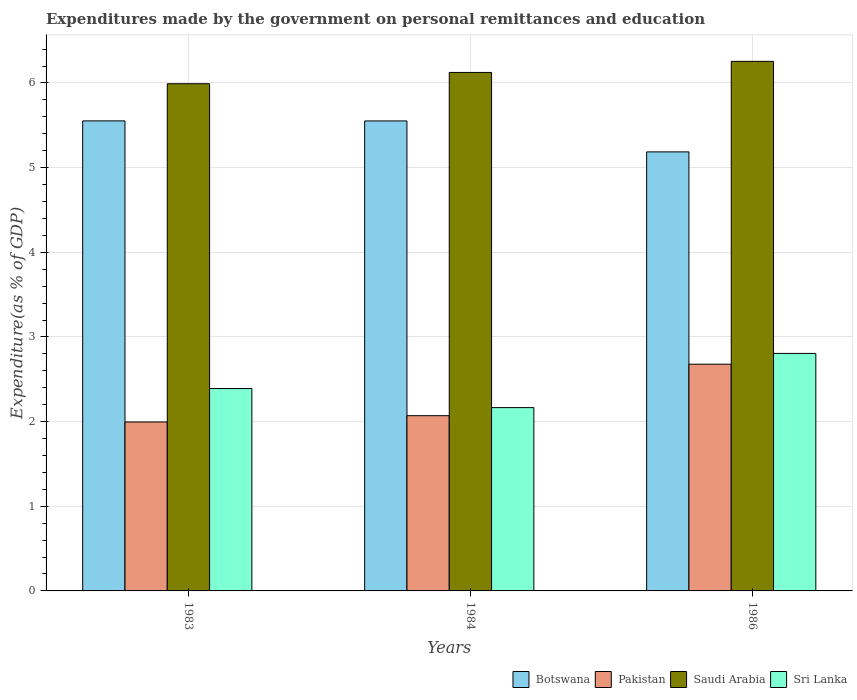How many groups of bars are there?
Provide a short and direct response. 3. Are the number of bars on each tick of the X-axis equal?
Offer a very short reply. Yes. How many bars are there on the 3rd tick from the right?
Offer a terse response. 4. What is the label of the 1st group of bars from the left?
Offer a very short reply. 1983. What is the expenditures made by the government on personal remittances and education in Sri Lanka in 1984?
Your response must be concise. 2.17. Across all years, what is the maximum expenditures made by the government on personal remittances and education in Saudi Arabia?
Your answer should be very brief. 6.26. Across all years, what is the minimum expenditures made by the government on personal remittances and education in Botswana?
Ensure brevity in your answer.  5.19. What is the total expenditures made by the government on personal remittances and education in Pakistan in the graph?
Provide a short and direct response. 6.74. What is the difference between the expenditures made by the government on personal remittances and education in Pakistan in 1983 and that in 1984?
Keep it short and to the point. -0.07. What is the difference between the expenditures made by the government on personal remittances and education in Sri Lanka in 1986 and the expenditures made by the government on personal remittances and education in Pakistan in 1984?
Provide a succinct answer. 0.74. What is the average expenditures made by the government on personal remittances and education in Saudi Arabia per year?
Offer a terse response. 6.12. In the year 1986, what is the difference between the expenditures made by the government on personal remittances and education in Sri Lanka and expenditures made by the government on personal remittances and education in Pakistan?
Provide a short and direct response. 0.13. In how many years, is the expenditures made by the government on personal remittances and education in Pakistan greater than 4.8 %?
Offer a terse response. 0. What is the ratio of the expenditures made by the government on personal remittances and education in Pakistan in 1984 to that in 1986?
Provide a short and direct response. 0.77. Is the expenditures made by the government on personal remittances and education in Saudi Arabia in 1983 less than that in 1986?
Offer a terse response. Yes. What is the difference between the highest and the second highest expenditures made by the government on personal remittances and education in Saudi Arabia?
Make the answer very short. 0.13. What is the difference between the highest and the lowest expenditures made by the government on personal remittances and education in Pakistan?
Give a very brief answer. 0.68. What does the 1st bar from the left in 1984 represents?
Offer a very short reply. Botswana. What does the 4th bar from the right in 1984 represents?
Provide a short and direct response. Botswana. Is it the case that in every year, the sum of the expenditures made by the government on personal remittances and education in Botswana and expenditures made by the government on personal remittances and education in Saudi Arabia is greater than the expenditures made by the government on personal remittances and education in Pakistan?
Your answer should be very brief. Yes. How many bars are there?
Your answer should be very brief. 12. How many years are there in the graph?
Your answer should be compact. 3. Does the graph contain any zero values?
Your response must be concise. No. Does the graph contain grids?
Your response must be concise. Yes. How many legend labels are there?
Give a very brief answer. 4. What is the title of the graph?
Provide a succinct answer. Expenditures made by the government on personal remittances and education. Does "Aruba" appear as one of the legend labels in the graph?
Give a very brief answer. No. What is the label or title of the Y-axis?
Provide a short and direct response. Expenditure(as % of GDP). What is the Expenditure(as % of GDP) in Botswana in 1983?
Your response must be concise. 5.55. What is the Expenditure(as % of GDP) in Pakistan in 1983?
Provide a succinct answer. 2. What is the Expenditure(as % of GDP) in Saudi Arabia in 1983?
Ensure brevity in your answer.  5.99. What is the Expenditure(as % of GDP) in Sri Lanka in 1983?
Provide a succinct answer. 2.39. What is the Expenditure(as % of GDP) in Botswana in 1984?
Your response must be concise. 5.55. What is the Expenditure(as % of GDP) in Pakistan in 1984?
Make the answer very short. 2.07. What is the Expenditure(as % of GDP) of Saudi Arabia in 1984?
Your answer should be compact. 6.12. What is the Expenditure(as % of GDP) of Sri Lanka in 1984?
Make the answer very short. 2.17. What is the Expenditure(as % of GDP) of Botswana in 1986?
Your answer should be compact. 5.19. What is the Expenditure(as % of GDP) in Pakistan in 1986?
Your response must be concise. 2.68. What is the Expenditure(as % of GDP) in Saudi Arabia in 1986?
Provide a short and direct response. 6.26. What is the Expenditure(as % of GDP) in Sri Lanka in 1986?
Your answer should be very brief. 2.81. Across all years, what is the maximum Expenditure(as % of GDP) in Botswana?
Ensure brevity in your answer.  5.55. Across all years, what is the maximum Expenditure(as % of GDP) of Pakistan?
Provide a short and direct response. 2.68. Across all years, what is the maximum Expenditure(as % of GDP) in Saudi Arabia?
Keep it short and to the point. 6.26. Across all years, what is the maximum Expenditure(as % of GDP) in Sri Lanka?
Give a very brief answer. 2.81. Across all years, what is the minimum Expenditure(as % of GDP) of Botswana?
Offer a very short reply. 5.19. Across all years, what is the minimum Expenditure(as % of GDP) of Pakistan?
Make the answer very short. 2. Across all years, what is the minimum Expenditure(as % of GDP) in Saudi Arabia?
Provide a short and direct response. 5.99. Across all years, what is the minimum Expenditure(as % of GDP) of Sri Lanka?
Provide a short and direct response. 2.17. What is the total Expenditure(as % of GDP) in Botswana in the graph?
Your answer should be compact. 16.29. What is the total Expenditure(as % of GDP) of Pakistan in the graph?
Keep it short and to the point. 6.74. What is the total Expenditure(as % of GDP) in Saudi Arabia in the graph?
Offer a terse response. 18.37. What is the total Expenditure(as % of GDP) of Sri Lanka in the graph?
Your answer should be compact. 7.36. What is the difference between the Expenditure(as % of GDP) of Botswana in 1983 and that in 1984?
Make the answer very short. 0. What is the difference between the Expenditure(as % of GDP) of Pakistan in 1983 and that in 1984?
Give a very brief answer. -0.07. What is the difference between the Expenditure(as % of GDP) in Saudi Arabia in 1983 and that in 1984?
Provide a short and direct response. -0.13. What is the difference between the Expenditure(as % of GDP) in Sri Lanka in 1983 and that in 1984?
Provide a succinct answer. 0.23. What is the difference between the Expenditure(as % of GDP) in Botswana in 1983 and that in 1986?
Make the answer very short. 0.37. What is the difference between the Expenditure(as % of GDP) in Pakistan in 1983 and that in 1986?
Offer a very short reply. -0.68. What is the difference between the Expenditure(as % of GDP) of Saudi Arabia in 1983 and that in 1986?
Provide a succinct answer. -0.26. What is the difference between the Expenditure(as % of GDP) in Sri Lanka in 1983 and that in 1986?
Your answer should be very brief. -0.41. What is the difference between the Expenditure(as % of GDP) in Botswana in 1984 and that in 1986?
Make the answer very short. 0.37. What is the difference between the Expenditure(as % of GDP) of Pakistan in 1984 and that in 1986?
Make the answer very short. -0.61. What is the difference between the Expenditure(as % of GDP) in Saudi Arabia in 1984 and that in 1986?
Provide a short and direct response. -0.13. What is the difference between the Expenditure(as % of GDP) in Sri Lanka in 1984 and that in 1986?
Provide a succinct answer. -0.64. What is the difference between the Expenditure(as % of GDP) of Botswana in 1983 and the Expenditure(as % of GDP) of Pakistan in 1984?
Your answer should be compact. 3.48. What is the difference between the Expenditure(as % of GDP) of Botswana in 1983 and the Expenditure(as % of GDP) of Saudi Arabia in 1984?
Your answer should be very brief. -0.57. What is the difference between the Expenditure(as % of GDP) in Botswana in 1983 and the Expenditure(as % of GDP) in Sri Lanka in 1984?
Ensure brevity in your answer.  3.39. What is the difference between the Expenditure(as % of GDP) in Pakistan in 1983 and the Expenditure(as % of GDP) in Saudi Arabia in 1984?
Your answer should be very brief. -4.13. What is the difference between the Expenditure(as % of GDP) of Pakistan in 1983 and the Expenditure(as % of GDP) of Sri Lanka in 1984?
Your answer should be very brief. -0.17. What is the difference between the Expenditure(as % of GDP) of Saudi Arabia in 1983 and the Expenditure(as % of GDP) of Sri Lanka in 1984?
Make the answer very short. 3.83. What is the difference between the Expenditure(as % of GDP) of Botswana in 1983 and the Expenditure(as % of GDP) of Pakistan in 1986?
Provide a short and direct response. 2.87. What is the difference between the Expenditure(as % of GDP) of Botswana in 1983 and the Expenditure(as % of GDP) of Saudi Arabia in 1986?
Keep it short and to the point. -0.7. What is the difference between the Expenditure(as % of GDP) in Botswana in 1983 and the Expenditure(as % of GDP) in Sri Lanka in 1986?
Ensure brevity in your answer.  2.75. What is the difference between the Expenditure(as % of GDP) in Pakistan in 1983 and the Expenditure(as % of GDP) in Saudi Arabia in 1986?
Give a very brief answer. -4.26. What is the difference between the Expenditure(as % of GDP) of Pakistan in 1983 and the Expenditure(as % of GDP) of Sri Lanka in 1986?
Your answer should be very brief. -0.81. What is the difference between the Expenditure(as % of GDP) of Saudi Arabia in 1983 and the Expenditure(as % of GDP) of Sri Lanka in 1986?
Ensure brevity in your answer.  3.19. What is the difference between the Expenditure(as % of GDP) of Botswana in 1984 and the Expenditure(as % of GDP) of Pakistan in 1986?
Offer a very short reply. 2.87. What is the difference between the Expenditure(as % of GDP) of Botswana in 1984 and the Expenditure(as % of GDP) of Saudi Arabia in 1986?
Your answer should be compact. -0.7. What is the difference between the Expenditure(as % of GDP) in Botswana in 1984 and the Expenditure(as % of GDP) in Sri Lanka in 1986?
Make the answer very short. 2.75. What is the difference between the Expenditure(as % of GDP) of Pakistan in 1984 and the Expenditure(as % of GDP) of Saudi Arabia in 1986?
Offer a terse response. -4.19. What is the difference between the Expenditure(as % of GDP) in Pakistan in 1984 and the Expenditure(as % of GDP) in Sri Lanka in 1986?
Offer a terse response. -0.74. What is the difference between the Expenditure(as % of GDP) of Saudi Arabia in 1984 and the Expenditure(as % of GDP) of Sri Lanka in 1986?
Offer a terse response. 3.32. What is the average Expenditure(as % of GDP) in Botswana per year?
Provide a short and direct response. 5.43. What is the average Expenditure(as % of GDP) in Pakistan per year?
Your answer should be compact. 2.25. What is the average Expenditure(as % of GDP) in Saudi Arabia per year?
Make the answer very short. 6.12. What is the average Expenditure(as % of GDP) in Sri Lanka per year?
Your response must be concise. 2.45. In the year 1983, what is the difference between the Expenditure(as % of GDP) in Botswana and Expenditure(as % of GDP) in Pakistan?
Your response must be concise. 3.56. In the year 1983, what is the difference between the Expenditure(as % of GDP) in Botswana and Expenditure(as % of GDP) in Saudi Arabia?
Provide a short and direct response. -0.44. In the year 1983, what is the difference between the Expenditure(as % of GDP) in Botswana and Expenditure(as % of GDP) in Sri Lanka?
Your answer should be compact. 3.16. In the year 1983, what is the difference between the Expenditure(as % of GDP) in Pakistan and Expenditure(as % of GDP) in Saudi Arabia?
Ensure brevity in your answer.  -4. In the year 1983, what is the difference between the Expenditure(as % of GDP) of Pakistan and Expenditure(as % of GDP) of Sri Lanka?
Provide a short and direct response. -0.39. In the year 1983, what is the difference between the Expenditure(as % of GDP) in Saudi Arabia and Expenditure(as % of GDP) in Sri Lanka?
Your answer should be compact. 3.6. In the year 1984, what is the difference between the Expenditure(as % of GDP) in Botswana and Expenditure(as % of GDP) in Pakistan?
Ensure brevity in your answer.  3.48. In the year 1984, what is the difference between the Expenditure(as % of GDP) in Botswana and Expenditure(as % of GDP) in Saudi Arabia?
Make the answer very short. -0.57. In the year 1984, what is the difference between the Expenditure(as % of GDP) of Botswana and Expenditure(as % of GDP) of Sri Lanka?
Provide a short and direct response. 3.39. In the year 1984, what is the difference between the Expenditure(as % of GDP) of Pakistan and Expenditure(as % of GDP) of Saudi Arabia?
Give a very brief answer. -4.05. In the year 1984, what is the difference between the Expenditure(as % of GDP) of Pakistan and Expenditure(as % of GDP) of Sri Lanka?
Your response must be concise. -0.1. In the year 1984, what is the difference between the Expenditure(as % of GDP) of Saudi Arabia and Expenditure(as % of GDP) of Sri Lanka?
Provide a succinct answer. 3.96. In the year 1986, what is the difference between the Expenditure(as % of GDP) of Botswana and Expenditure(as % of GDP) of Pakistan?
Make the answer very short. 2.51. In the year 1986, what is the difference between the Expenditure(as % of GDP) in Botswana and Expenditure(as % of GDP) in Saudi Arabia?
Keep it short and to the point. -1.07. In the year 1986, what is the difference between the Expenditure(as % of GDP) in Botswana and Expenditure(as % of GDP) in Sri Lanka?
Provide a short and direct response. 2.38. In the year 1986, what is the difference between the Expenditure(as % of GDP) of Pakistan and Expenditure(as % of GDP) of Saudi Arabia?
Your response must be concise. -3.58. In the year 1986, what is the difference between the Expenditure(as % of GDP) of Pakistan and Expenditure(as % of GDP) of Sri Lanka?
Provide a short and direct response. -0.13. In the year 1986, what is the difference between the Expenditure(as % of GDP) of Saudi Arabia and Expenditure(as % of GDP) of Sri Lanka?
Your answer should be very brief. 3.45. What is the ratio of the Expenditure(as % of GDP) of Pakistan in 1983 to that in 1984?
Your answer should be compact. 0.96. What is the ratio of the Expenditure(as % of GDP) in Saudi Arabia in 1983 to that in 1984?
Your response must be concise. 0.98. What is the ratio of the Expenditure(as % of GDP) in Sri Lanka in 1983 to that in 1984?
Your answer should be very brief. 1.1. What is the ratio of the Expenditure(as % of GDP) of Botswana in 1983 to that in 1986?
Provide a succinct answer. 1.07. What is the ratio of the Expenditure(as % of GDP) in Pakistan in 1983 to that in 1986?
Give a very brief answer. 0.75. What is the ratio of the Expenditure(as % of GDP) of Saudi Arabia in 1983 to that in 1986?
Give a very brief answer. 0.96. What is the ratio of the Expenditure(as % of GDP) of Sri Lanka in 1983 to that in 1986?
Make the answer very short. 0.85. What is the ratio of the Expenditure(as % of GDP) in Botswana in 1984 to that in 1986?
Your response must be concise. 1.07. What is the ratio of the Expenditure(as % of GDP) in Pakistan in 1984 to that in 1986?
Your response must be concise. 0.77. What is the ratio of the Expenditure(as % of GDP) in Saudi Arabia in 1984 to that in 1986?
Your answer should be very brief. 0.98. What is the ratio of the Expenditure(as % of GDP) in Sri Lanka in 1984 to that in 1986?
Ensure brevity in your answer.  0.77. What is the difference between the highest and the second highest Expenditure(as % of GDP) in Botswana?
Provide a succinct answer. 0. What is the difference between the highest and the second highest Expenditure(as % of GDP) in Pakistan?
Make the answer very short. 0.61. What is the difference between the highest and the second highest Expenditure(as % of GDP) in Saudi Arabia?
Provide a short and direct response. 0.13. What is the difference between the highest and the second highest Expenditure(as % of GDP) in Sri Lanka?
Offer a very short reply. 0.41. What is the difference between the highest and the lowest Expenditure(as % of GDP) in Botswana?
Provide a succinct answer. 0.37. What is the difference between the highest and the lowest Expenditure(as % of GDP) in Pakistan?
Give a very brief answer. 0.68. What is the difference between the highest and the lowest Expenditure(as % of GDP) of Saudi Arabia?
Provide a short and direct response. 0.26. What is the difference between the highest and the lowest Expenditure(as % of GDP) of Sri Lanka?
Ensure brevity in your answer.  0.64. 